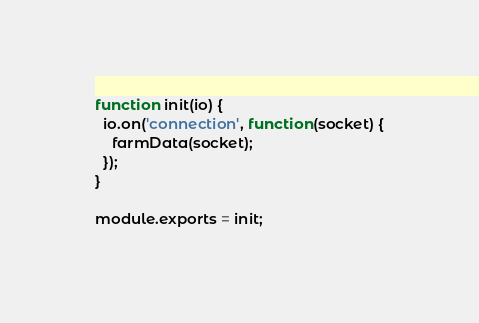<code> <loc_0><loc_0><loc_500><loc_500><_JavaScript_>
function init(io) {
  io.on('connection', function(socket) {
    farmData(socket);
  });
}

module.exports = init;
</code> 